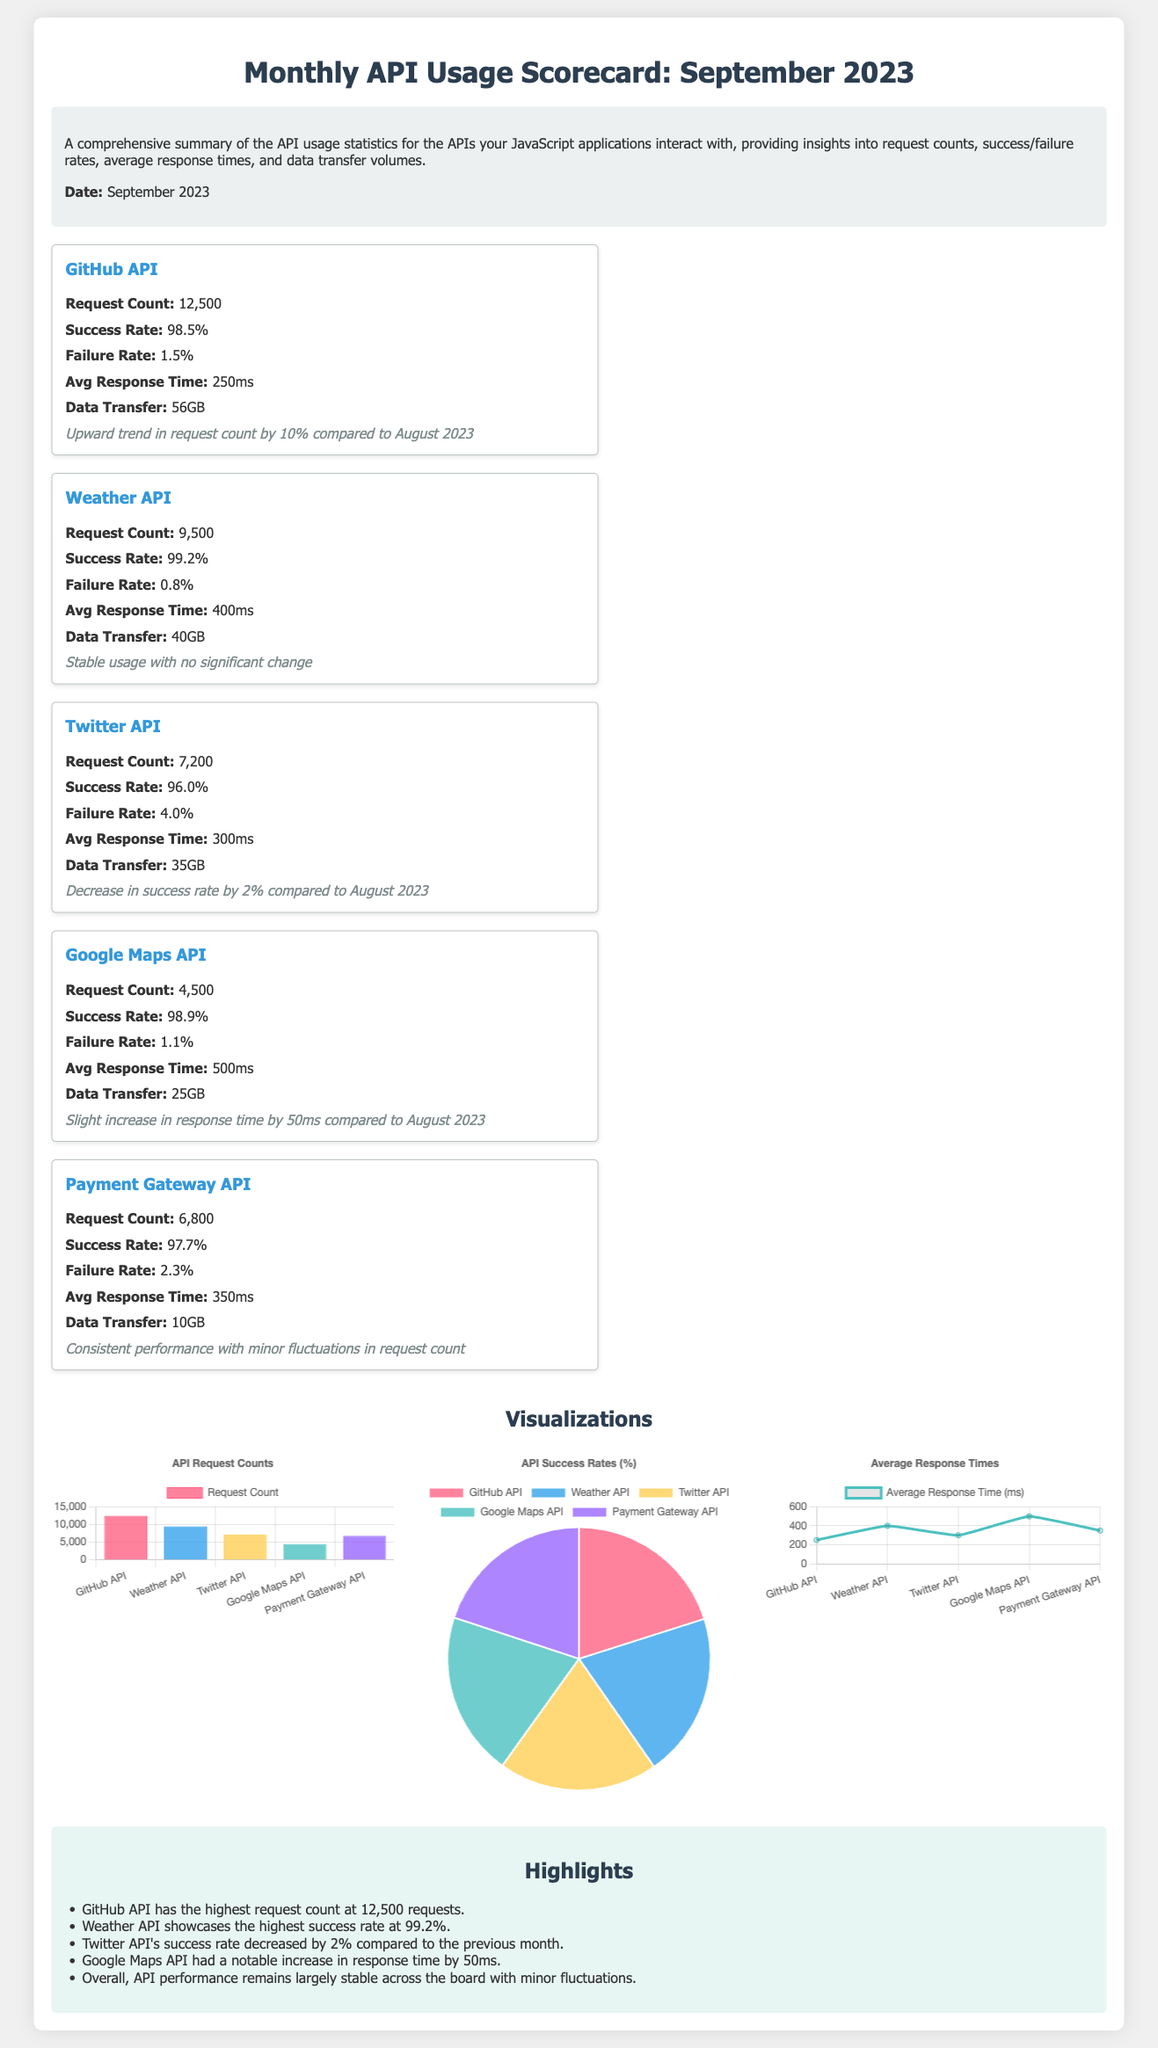what is the total request count for GitHub API? The request count for GitHub API is explicitly mentioned in the document as 12,500.
Answer: 12,500 what is the success rate of the Weather API? The success rate for the Weather API is detailed in the document, stated as 99.2%.
Answer: 99.2% which API shows a decrease in success rate compared to August 2023? The document highlights that the Twitter API's success rate decreased by 2%.
Answer: Twitter API what was the average response time for the Google Maps API? The document provides the average response time for Google Maps API as 500 milliseconds.
Answer: 500ms which API has the highest data transfer volume? The GitHub API has the highest data transfer volume at 56GB according to the document.
Answer: 56GB what is the general trend of API performance as mentioned in the highlights? The highlights section states that overall, API performance remains largely stable across the board.
Answer: Stable how many APIs are listed in the scorecard? The scorecard includes a total of five APIs for the month of September 2023.
Answer: Five APIs what type of chart is used to display the success rates? The document describes the chart type used for success rates as a pie chart.
Answer: Pie chart what is the average response time for the Twitter API? The average response time for the Twitter API is specified in the document as 300 milliseconds.
Answer: 300ms 